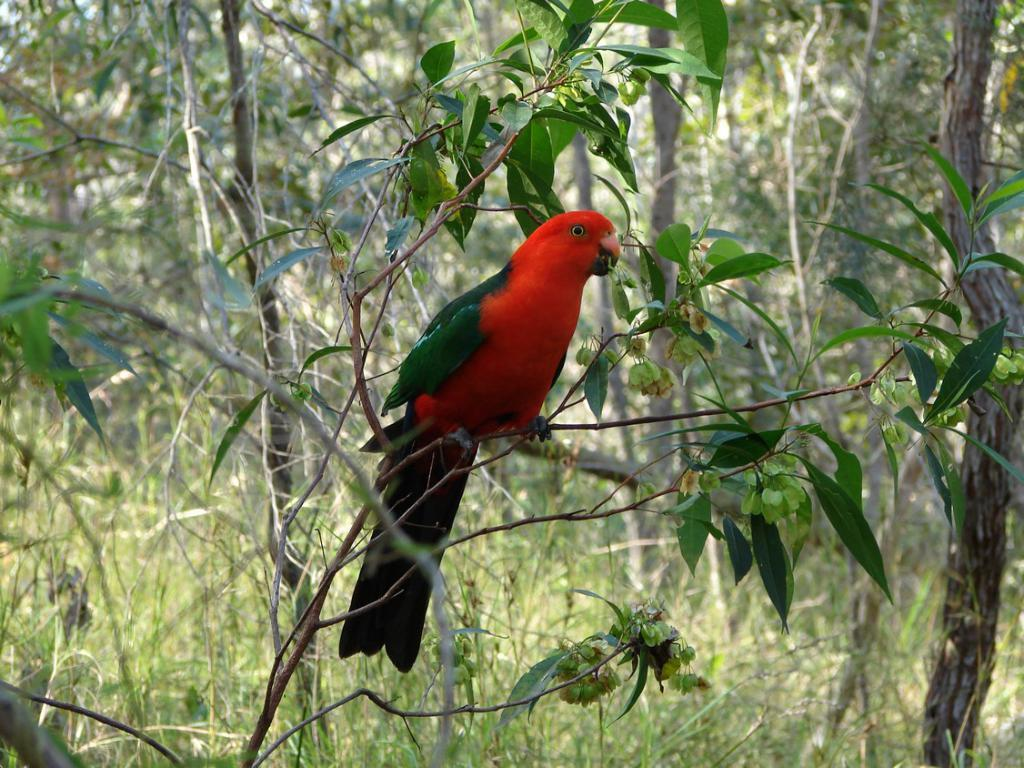What type of animal is in the image? There is a red color parrot in the image. Where is the parrot located? The parrot is on the branch of a tree. How many trees can be seen in the image? There are multiple trees visible in the image. What type of paper is the parrot using to write its answers? There is no paper present in the image, and parrots do not have the ability to write. 